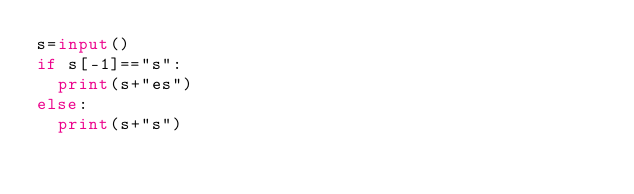<code> <loc_0><loc_0><loc_500><loc_500><_Python_>s=input()
if s[-1]=="s":
  print(s+"es")
else:
  print(s+"s")</code> 